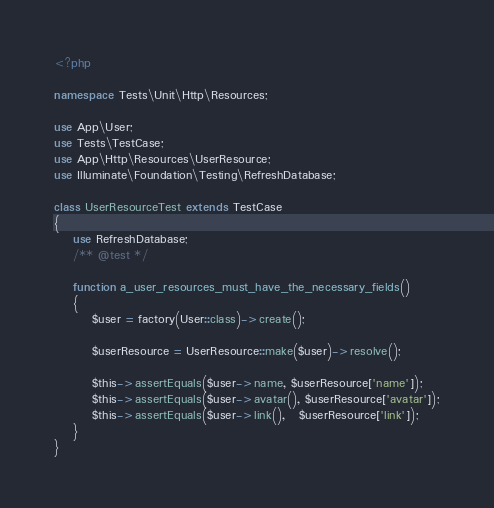<code> <loc_0><loc_0><loc_500><loc_500><_PHP_><?php

namespace Tests\Unit\Http\Resources;

use App\User;
use Tests\TestCase;
use App\Http\Resources\UserResource;
use Illuminate\Foundation\Testing\RefreshDatabase;

class UserResourceTest extends TestCase
{
    use RefreshDatabase;
    /** @test */

    function a_user_resources_must_have_the_necessary_fields()
    {
        $user = factory(User::class)->create();

        $userResource = UserResource::make($user)->resolve();

        $this->assertEquals($user->name, $userResource['name']);
        $this->assertEquals($user->avatar(), $userResource['avatar']);
        $this->assertEquals($user->link(),   $userResource['link']);
    }
}
</code> 